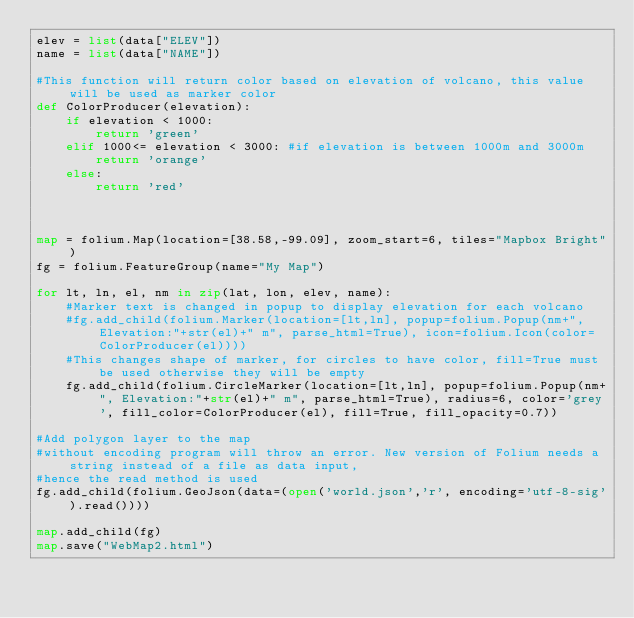<code> <loc_0><loc_0><loc_500><loc_500><_Python_>elev = list(data["ELEV"])
name = list(data["NAME"])

#This function will return color based on elevation of volcano, this value will be used as marker color
def ColorProducer(elevation):
    if elevation < 1000:
        return 'green'
    elif 1000<= elevation < 3000: #if elevation is between 1000m and 3000m
        return 'orange'
    else:
        return 'red'
    
    

map = folium.Map(location=[38.58,-99.09], zoom_start=6, tiles="Mapbox Bright")
fg = folium.FeatureGroup(name="My Map")

for lt, ln, el, nm in zip(lat, lon, elev, name):
    #Marker text is changed in popup to display elevation for each volcano
    #fg.add_child(folium.Marker(location=[lt,ln], popup=folium.Popup(nm+", Elevation:"+str(el)+" m", parse_html=True), icon=folium.Icon(color=ColorProducer(el))))
    #This changes shape of marker, for circles to have color, fill=True must be used otherwise they will be empty
    fg.add_child(folium.CircleMarker(location=[lt,ln], popup=folium.Popup(nm+", Elevation:"+str(el)+" m", parse_html=True), radius=6, color='grey', fill_color=ColorProducer(el), fill=True, fill_opacity=0.7))

#Add polygon layer to the map
#without encoding program will throw an error. New version of Folium needs a string instead of a file as data input, 
#hence the read method is used
fg.add_child(folium.GeoJson(data=(open('world.json','r', encoding='utf-8-sig').read())))

map.add_child(fg)
map.save("WebMap2.html")
</code> 